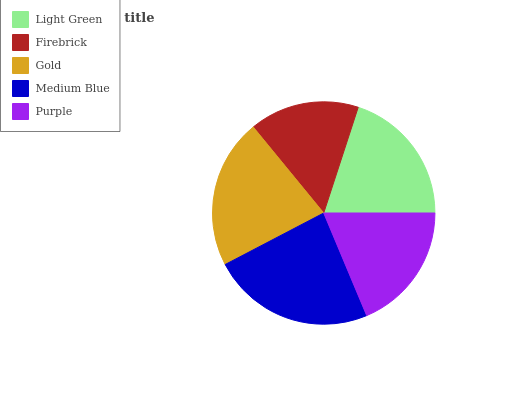Is Firebrick the minimum?
Answer yes or no. Yes. Is Medium Blue the maximum?
Answer yes or no. Yes. Is Gold the minimum?
Answer yes or no. No. Is Gold the maximum?
Answer yes or no. No. Is Gold greater than Firebrick?
Answer yes or no. Yes. Is Firebrick less than Gold?
Answer yes or no. Yes. Is Firebrick greater than Gold?
Answer yes or no. No. Is Gold less than Firebrick?
Answer yes or no. No. Is Light Green the high median?
Answer yes or no. Yes. Is Light Green the low median?
Answer yes or no. Yes. Is Gold the high median?
Answer yes or no. No. Is Gold the low median?
Answer yes or no. No. 